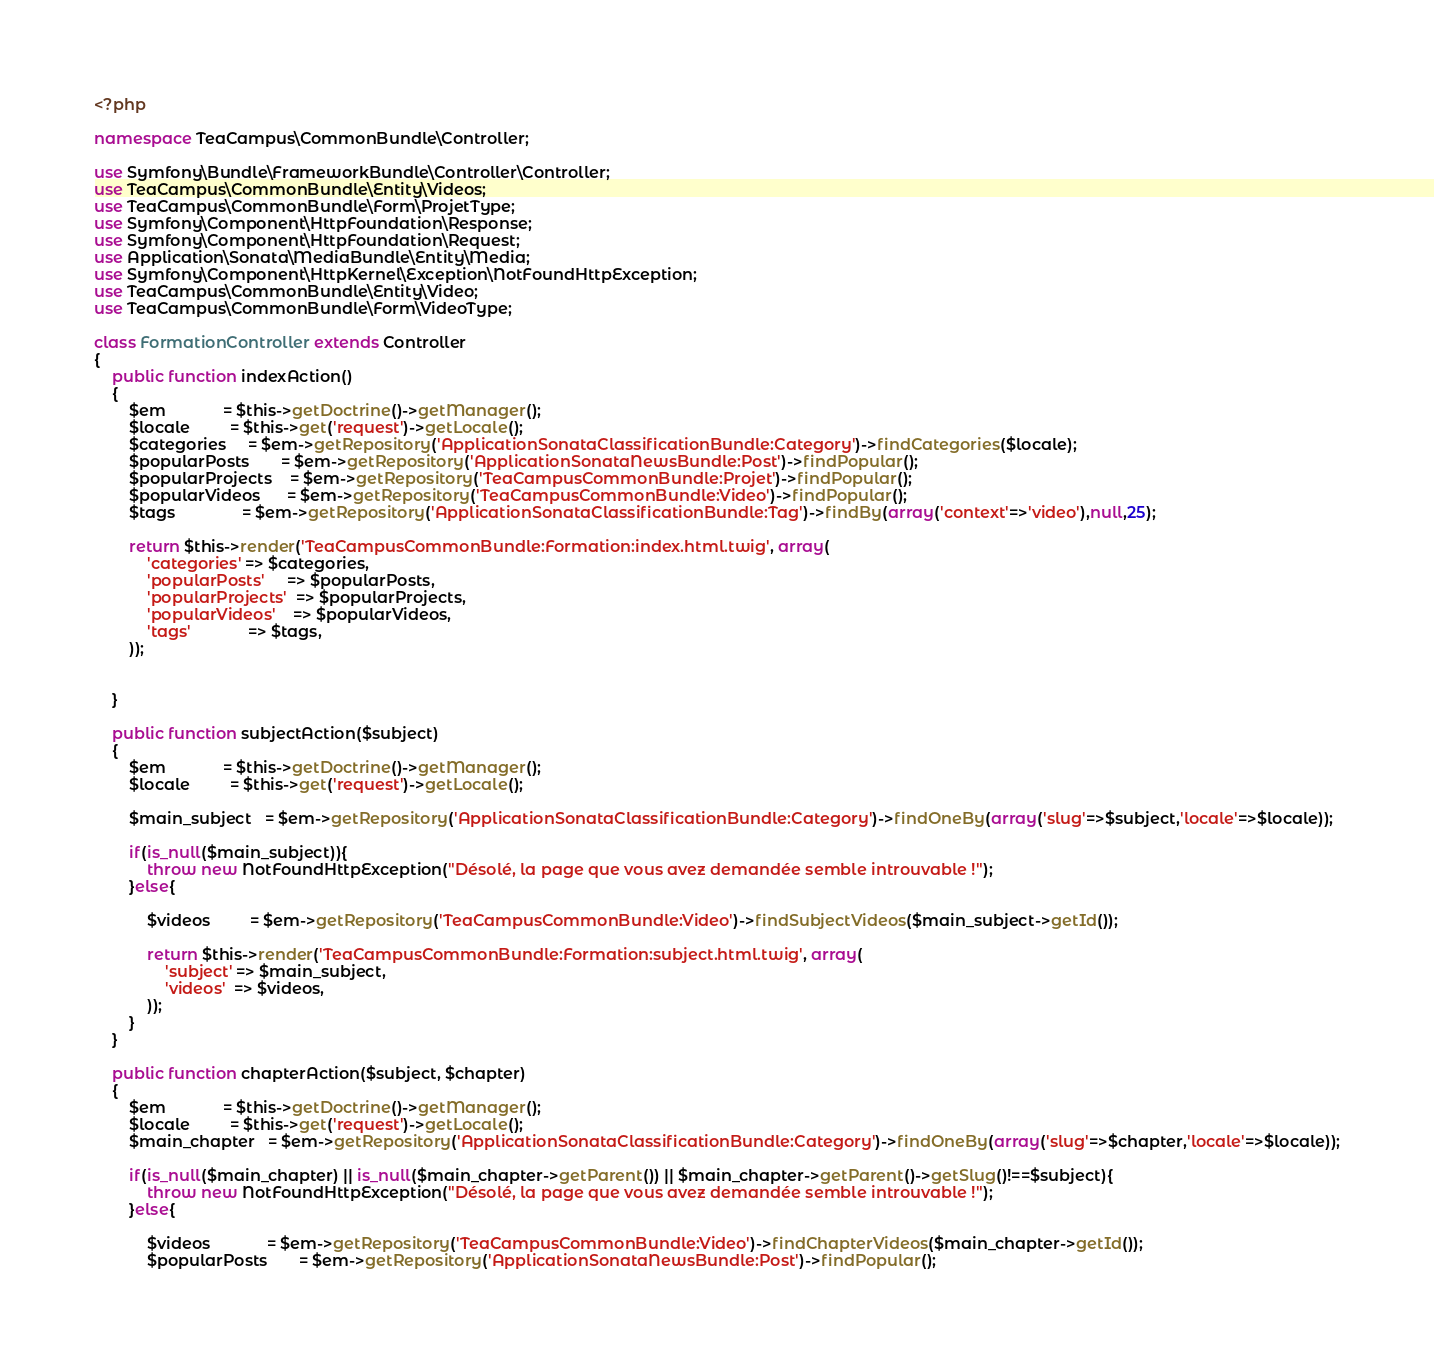<code> <loc_0><loc_0><loc_500><loc_500><_PHP_><?php

namespace TeaCampus\CommonBundle\Controller;

use Symfony\Bundle\FrameworkBundle\Controller\Controller;
use TeaCampus\CommonBundle\Entity\Videos;
use TeaCampus\CommonBundle\Form\ProjetType;
use Symfony\Component\HttpFoundation\Response;
use Symfony\Component\HttpFoundation\Request;
use Application\Sonata\MediaBundle\Entity\Media;
use Symfony\Component\HttpKernel\Exception\NotFoundHttpException;
use TeaCampus\CommonBundle\Entity\Video;
use TeaCampus\CommonBundle\Form\VideoType;

class FormationController extends Controller
{
    public function indexAction()
    {
        $em             = $this->getDoctrine()->getManager();
        $locale         = $this->get('request')->getLocale();
        $categories     = $em->getRepository('ApplicationSonataClassificationBundle:Category')->findCategories($locale);
        $popularPosts       = $em->getRepository('ApplicationSonataNewsBundle:Post')->findPopular();
        $popularProjects    = $em->getRepository('TeaCampusCommonBundle:Projet')->findPopular();
        $popularVideos      = $em->getRepository('TeaCampusCommonBundle:Video')->findPopular();
        $tags               = $em->getRepository('ApplicationSonataClassificationBundle:Tag')->findBy(array('context'=>'video'),null,25);
        
        return $this->render('TeaCampusCommonBundle:Formation:index.html.twig', array(
            'categories' => $categories,
            'popularPosts'     => $popularPosts,
            'popularProjects'  => $popularProjects,
            'popularVideos'    => $popularVideos,
            'tags'             => $tags,
        ));
        
       
    }
    
    public function subjectAction($subject)
    {
        $em             = $this->getDoctrine()->getManager();
        $locale         = $this->get('request')->getLocale();

        $main_subject   = $em->getRepository('ApplicationSonataClassificationBundle:Category')->findOneBy(array('slug'=>$subject,'locale'=>$locale));
        
        if(is_null($main_subject)){
            throw new NotFoundHttpException("Désolé, la page que vous avez demandée semble introuvable !");
        }else{
            
            $videos         = $em->getRepository('TeaCampusCommonBundle:Video')->findSubjectVideos($main_subject->getId());

            return $this->render('TeaCampusCommonBundle:Formation:subject.html.twig', array(
                'subject' => $main_subject,
                'videos'  => $videos,
            ));
        }
    }
    
    public function chapterAction($subject, $chapter)
    {
        $em             = $this->getDoctrine()->getManager();
        $locale         = $this->get('request')->getLocale();
        $main_chapter   = $em->getRepository('ApplicationSonataClassificationBundle:Category')->findOneBy(array('slug'=>$chapter,'locale'=>$locale));
        
        if(is_null($main_chapter) || is_null($main_chapter->getParent()) || $main_chapter->getParent()->getSlug()!==$subject){
            throw new NotFoundHttpException("Désolé, la page que vous avez demandée semble introuvable !");
        }else{
            
            $videos             = $em->getRepository('TeaCampusCommonBundle:Video')->findChapterVideos($main_chapter->getId());
            $popularPosts       = $em->getRepository('ApplicationSonataNewsBundle:Post')->findPopular();</code> 